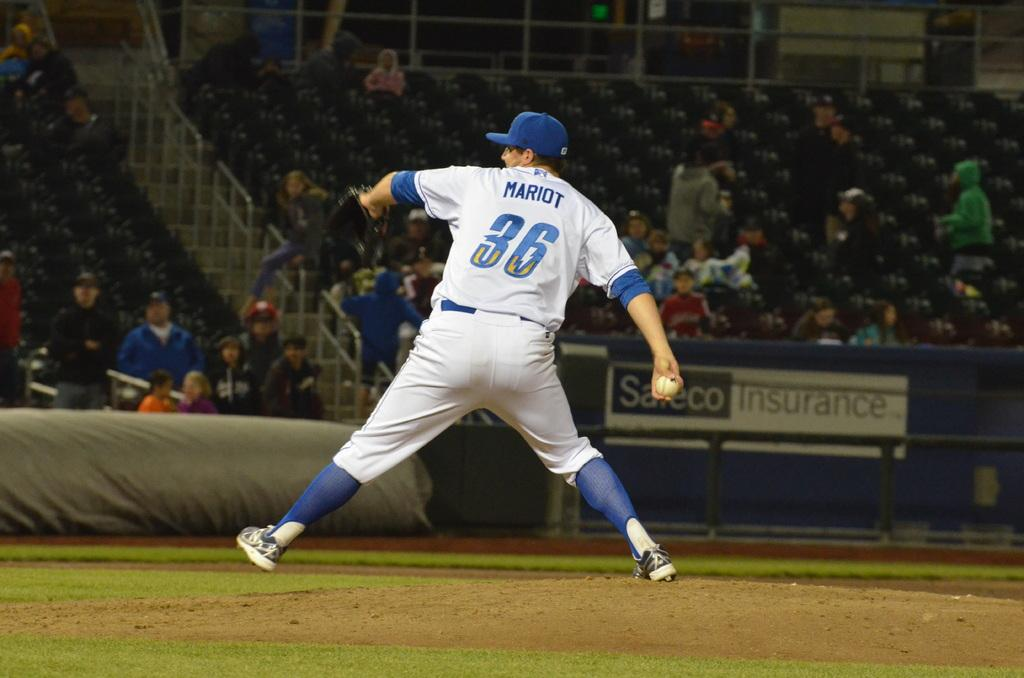<image>
Render a clear and concise summary of the photo. Pitcher in a white uniform with Mariot on the back of his jersey. 